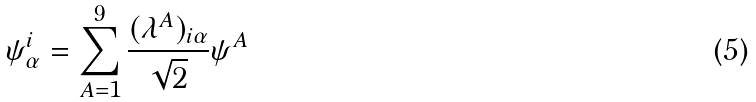Convert formula to latex. <formula><loc_0><loc_0><loc_500><loc_500>\psi ^ { i } _ { \alpha } = \sum _ { A = 1 } ^ { 9 } \frac { ( \lambda ^ { A } ) _ { i \alpha } } { \sqrt { 2 } } \psi ^ { A }</formula> 